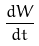<formula> <loc_0><loc_0><loc_500><loc_500>\frac { d W } { d t }</formula> 